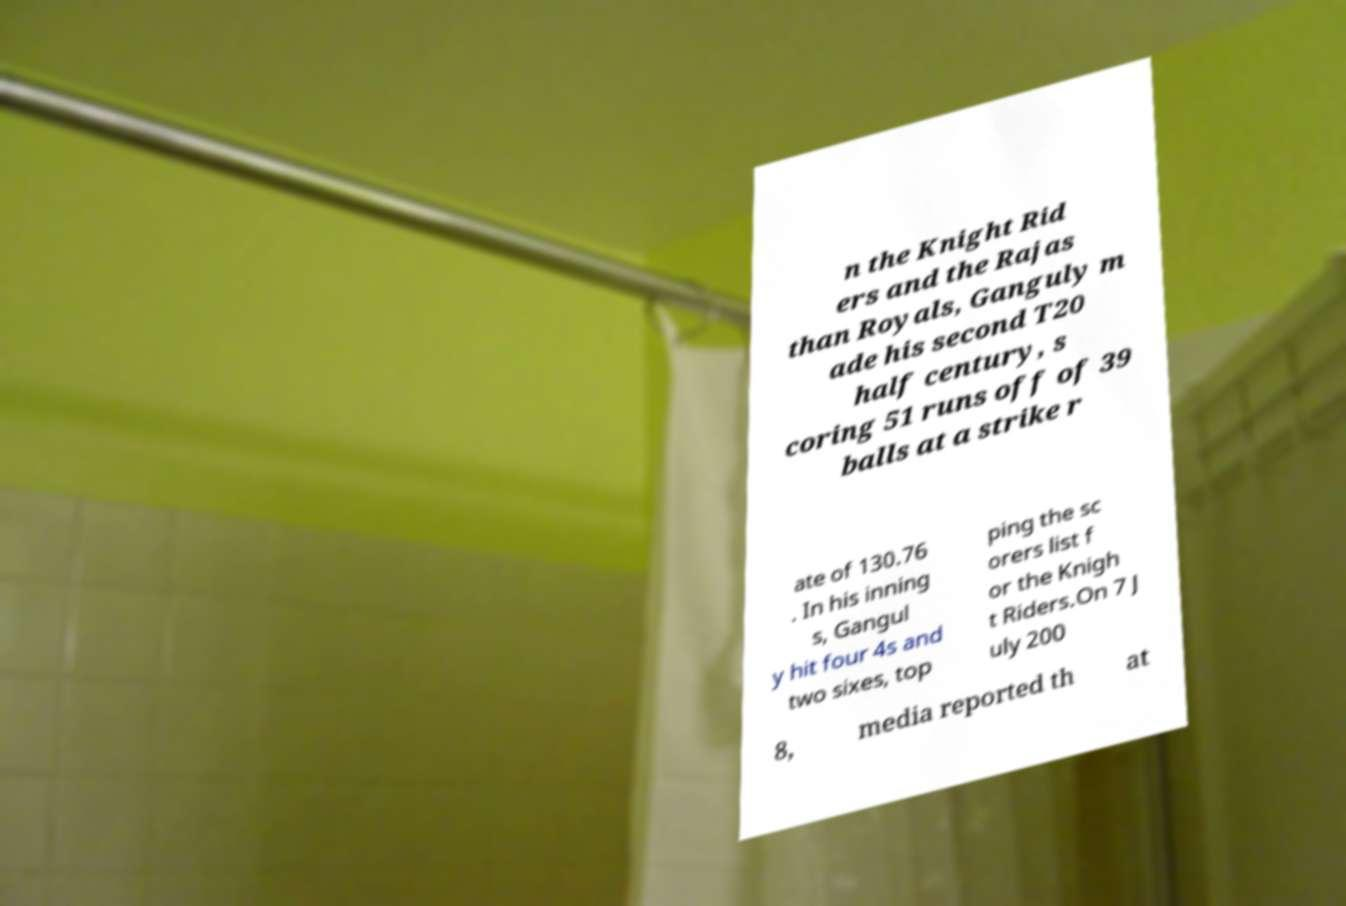Can you read and provide the text displayed in the image?This photo seems to have some interesting text. Can you extract and type it out for me? n the Knight Rid ers and the Rajas than Royals, Ganguly m ade his second T20 half century, s coring 51 runs off of 39 balls at a strike r ate of 130.76 . In his inning s, Gangul y hit four 4s and two sixes, top ping the sc orers list f or the Knigh t Riders.On 7 J uly 200 8, media reported th at 